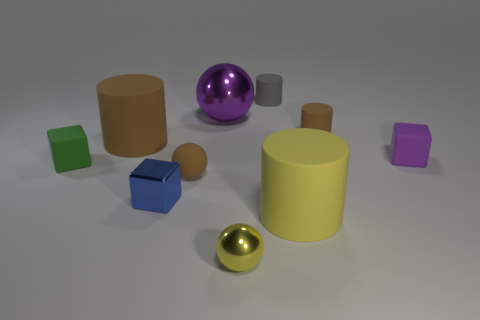Subtract all purple spheres. How many spheres are left? 2 Subtract 2 balls. How many balls are left? 1 Subtract all gray cylinders. How many cylinders are left? 3 Add 7 tiny green rubber cubes. How many tiny green rubber cubes exist? 8 Subtract 1 blue blocks. How many objects are left? 9 Subtract all cylinders. How many objects are left? 6 Subtract all cyan cylinders. Subtract all yellow balls. How many cylinders are left? 4 Subtract all cyan spheres. How many red cylinders are left? 0 Subtract all small cyan objects. Subtract all big brown rubber objects. How many objects are left? 9 Add 3 tiny gray objects. How many tiny gray objects are left? 4 